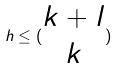<formula> <loc_0><loc_0><loc_500><loc_500>h \leq ( \begin{matrix} k + l \\ k \end{matrix} )</formula> 